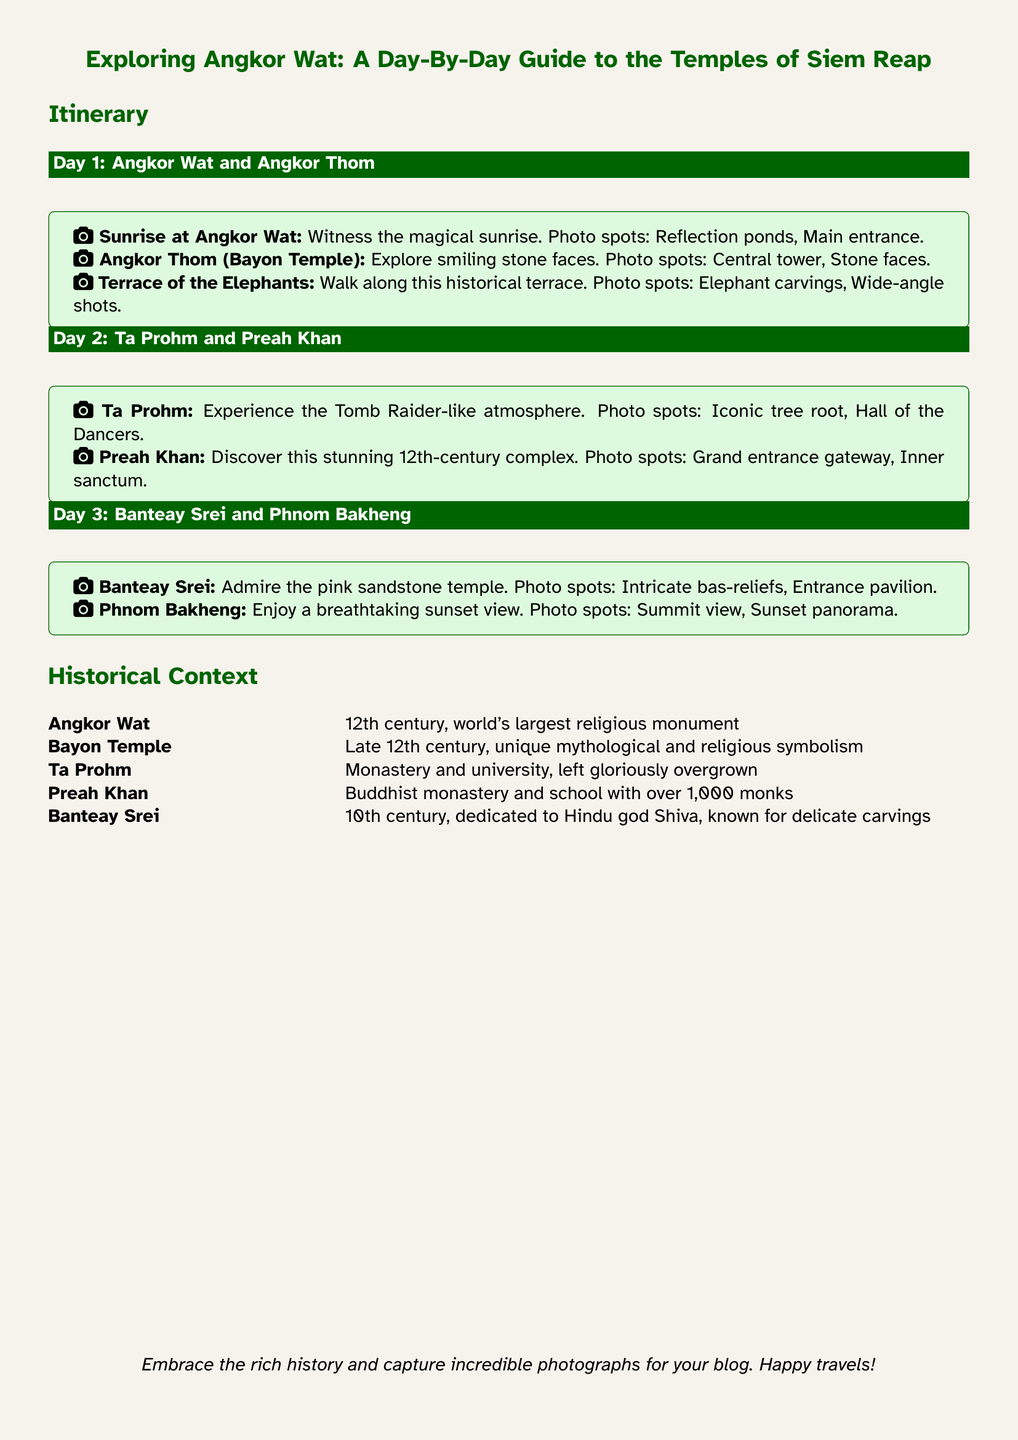What are the photo spots at Angkor Wat? The photo spots at Angkor Wat include reflection ponds and the main entrance.
Answer: Reflection ponds, Main entrance What century was Angkor Wat built? Angkor Wat was built in the 12th century.
Answer: 12th century Which temple features the Hall of the Dancers? Ta Prohm features the Hall of the Dancers.
Answer: Ta Prohm What is the historical significance of the Bayon Temple? The Bayon Temple is known for its unique mythological and religious symbolism.
Answer: Unique mythological and religious symbolism What kind of atmosphere does Ta Prohm provide? Ta Prohm provides a Tomb Raider-like atmosphere.
Answer: Tomb Raider-like atmosphere How many monks were associated with Preah Khan? Preah Khan had over 1,000 monks.
Answer: Over 1,000 monks What type of stone is Banteay Srei known for? Banteay Srei is known for its pink sandstone.
Answer: Pink sandstone What is the final day's activity in the itinerary? The final day's activity is enjoying a sunset view at Phnom Bakheng.
Answer: Enjoying a sunset view at Phnom Bakheng What year was Banteay Srei built? Banteay Srei was built in the 10th century.
Answer: 10th century 